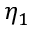<formula> <loc_0><loc_0><loc_500><loc_500>\eta _ { 1 }</formula> 